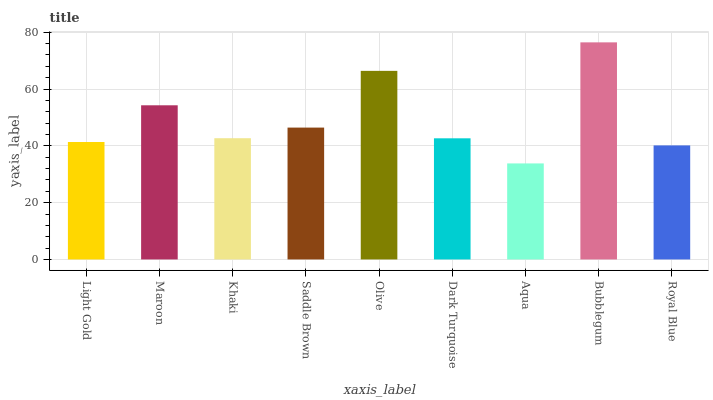Is Aqua the minimum?
Answer yes or no. Yes. Is Bubblegum the maximum?
Answer yes or no. Yes. Is Maroon the minimum?
Answer yes or no. No. Is Maroon the maximum?
Answer yes or no. No. Is Maroon greater than Light Gold?
Answer yes or no. Yes. Is Light Gold less than Maroon?
Answer yes or no. Yes. Is Light Gold greater than Maroon?
Answer yes or no. No. Is Maroon less than Light Gold?
Answer yes or no. No. Is Khaki the high median?
Answer yes or no. Yes. Is Khaki the low median?
Answer yes or no. Yes. Is Maroon the high median?
Answer yes or no. No. Is Dark Turquoise the low median?
Answer yes or no. No. 